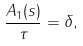Convert formula to latex. <formula><loc_0><loc_0><loc_500><loc_500>\frac { A _ { 1 } ( s ) } { \tau } = \delta ,</formula> 